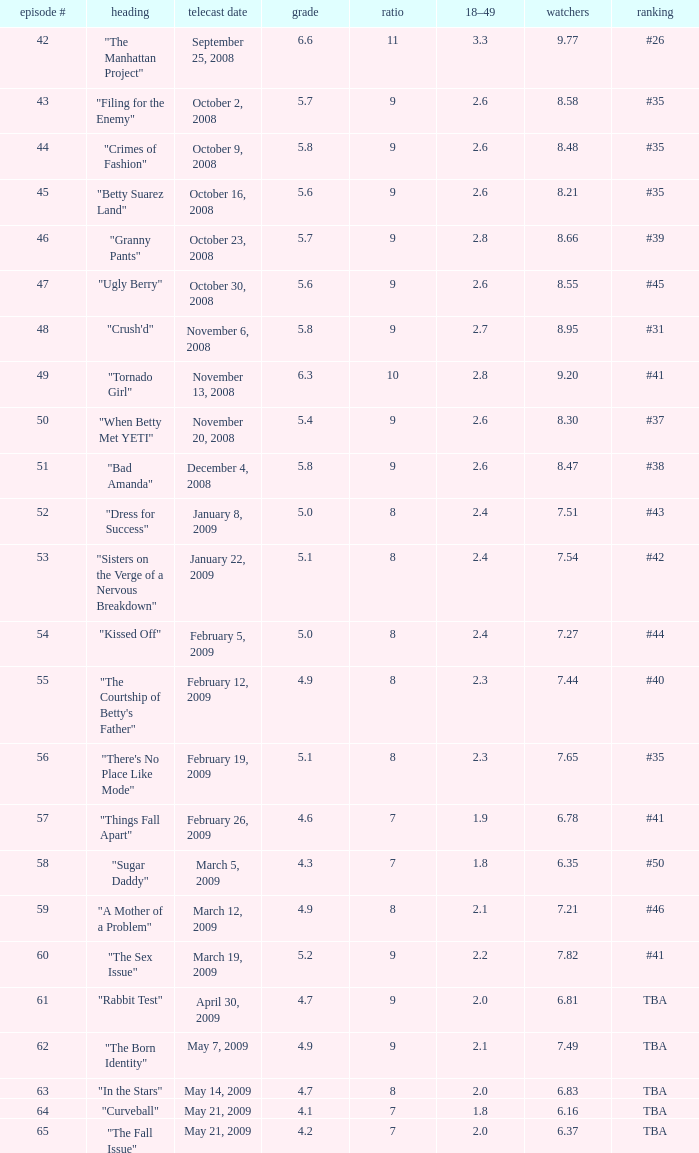What is the average Episode # with a share of 9, and #35 is rank and less than 8.21 viewers? None. 